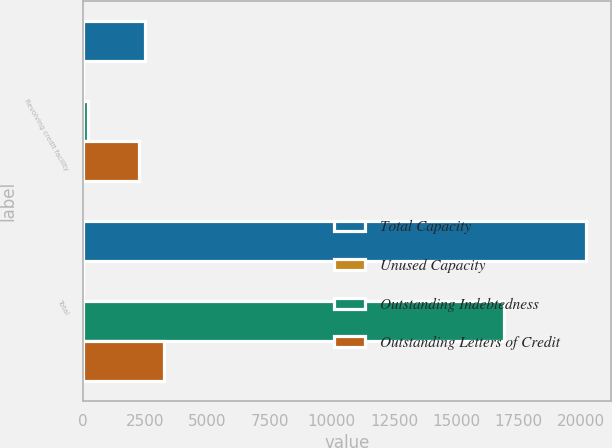<chart> <loc_0><loc_0><loc_500><loc_500><stacked_bar_chart><ecel><fcel>Revolving credit facility<fcel>Total<nl><fcel>Total Capacity<fcel>2500<fcel>20183<nl><fcel>Unused Capacity<fcel>1<fcel>1<nl><fcel>Outstanding Indebtedness<fcel>225<fcel>16918<nl><fcel>Outstanding Letters of Credit<fcel>2274<fcel>3264<nl></chart> 